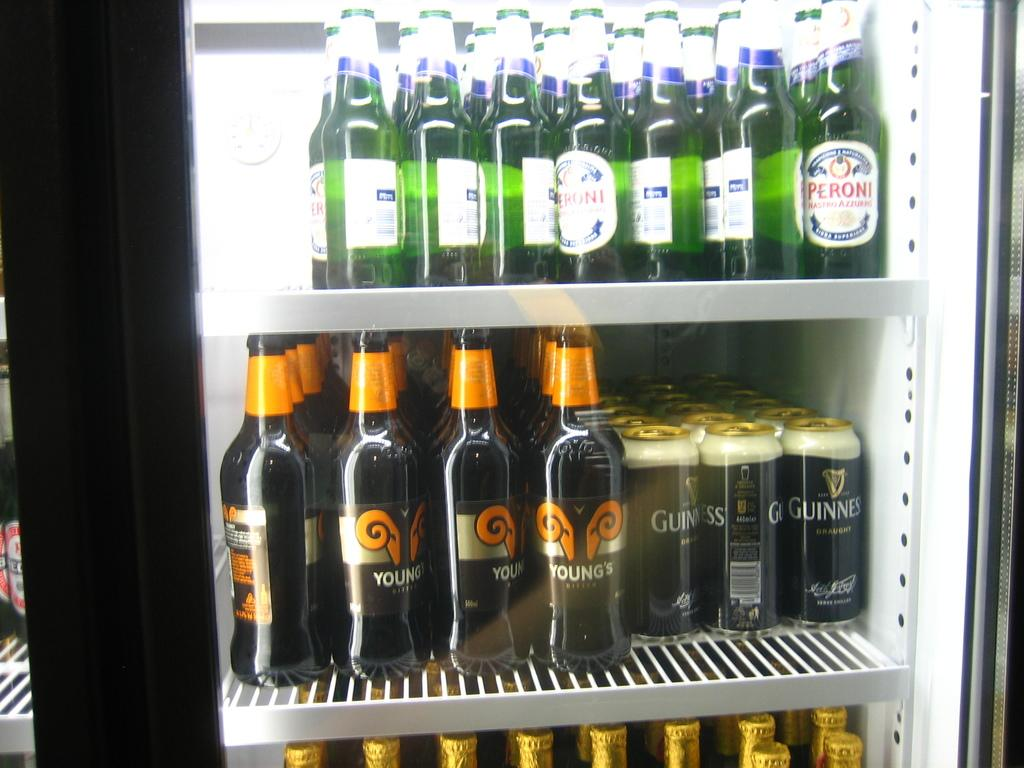What type of appliance is visible in the image? There is a refrigerator in the image. What items can be seen inside the refrigerator? The refrigerator contains wine bottles and tins on its shelves. Can you describe the layout of the image? There is another refrigerator on the left side of the image. What type of insect can be seen crawling on the hospital bed in the image? There is no insect or hospital bed present in the image; it features a refrigerator with wine bottles and tins on its shelves and another refrigerator on the left side. 